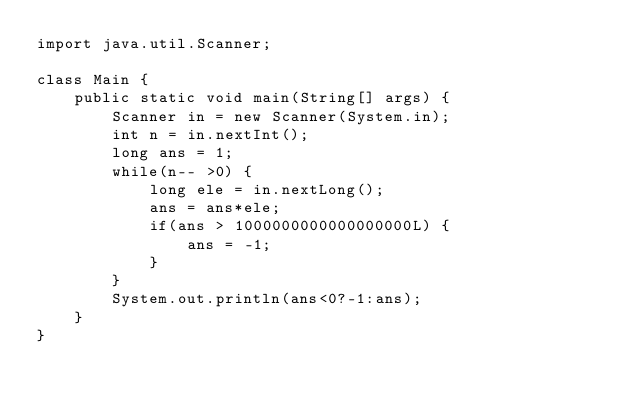Convert code to text. <code><loc_0><loc_0><loc_500><loc_500><_Java_>import java.util.Scanner;

class Main {    
    public static void main(String[] args) { 
        Scanner in = new Scanner(System.in);
      	int n = in.nextInt();
        long ans = 1;
        while(n-- >0) {
            long ele = in.nextLong();
            ans = ans*ele;
            if(ans > 1000000000000000000L) {
                ans = -1; 
            }    
        }
        System.out.println(ans<0?-1:ans);
    }
}</code> 